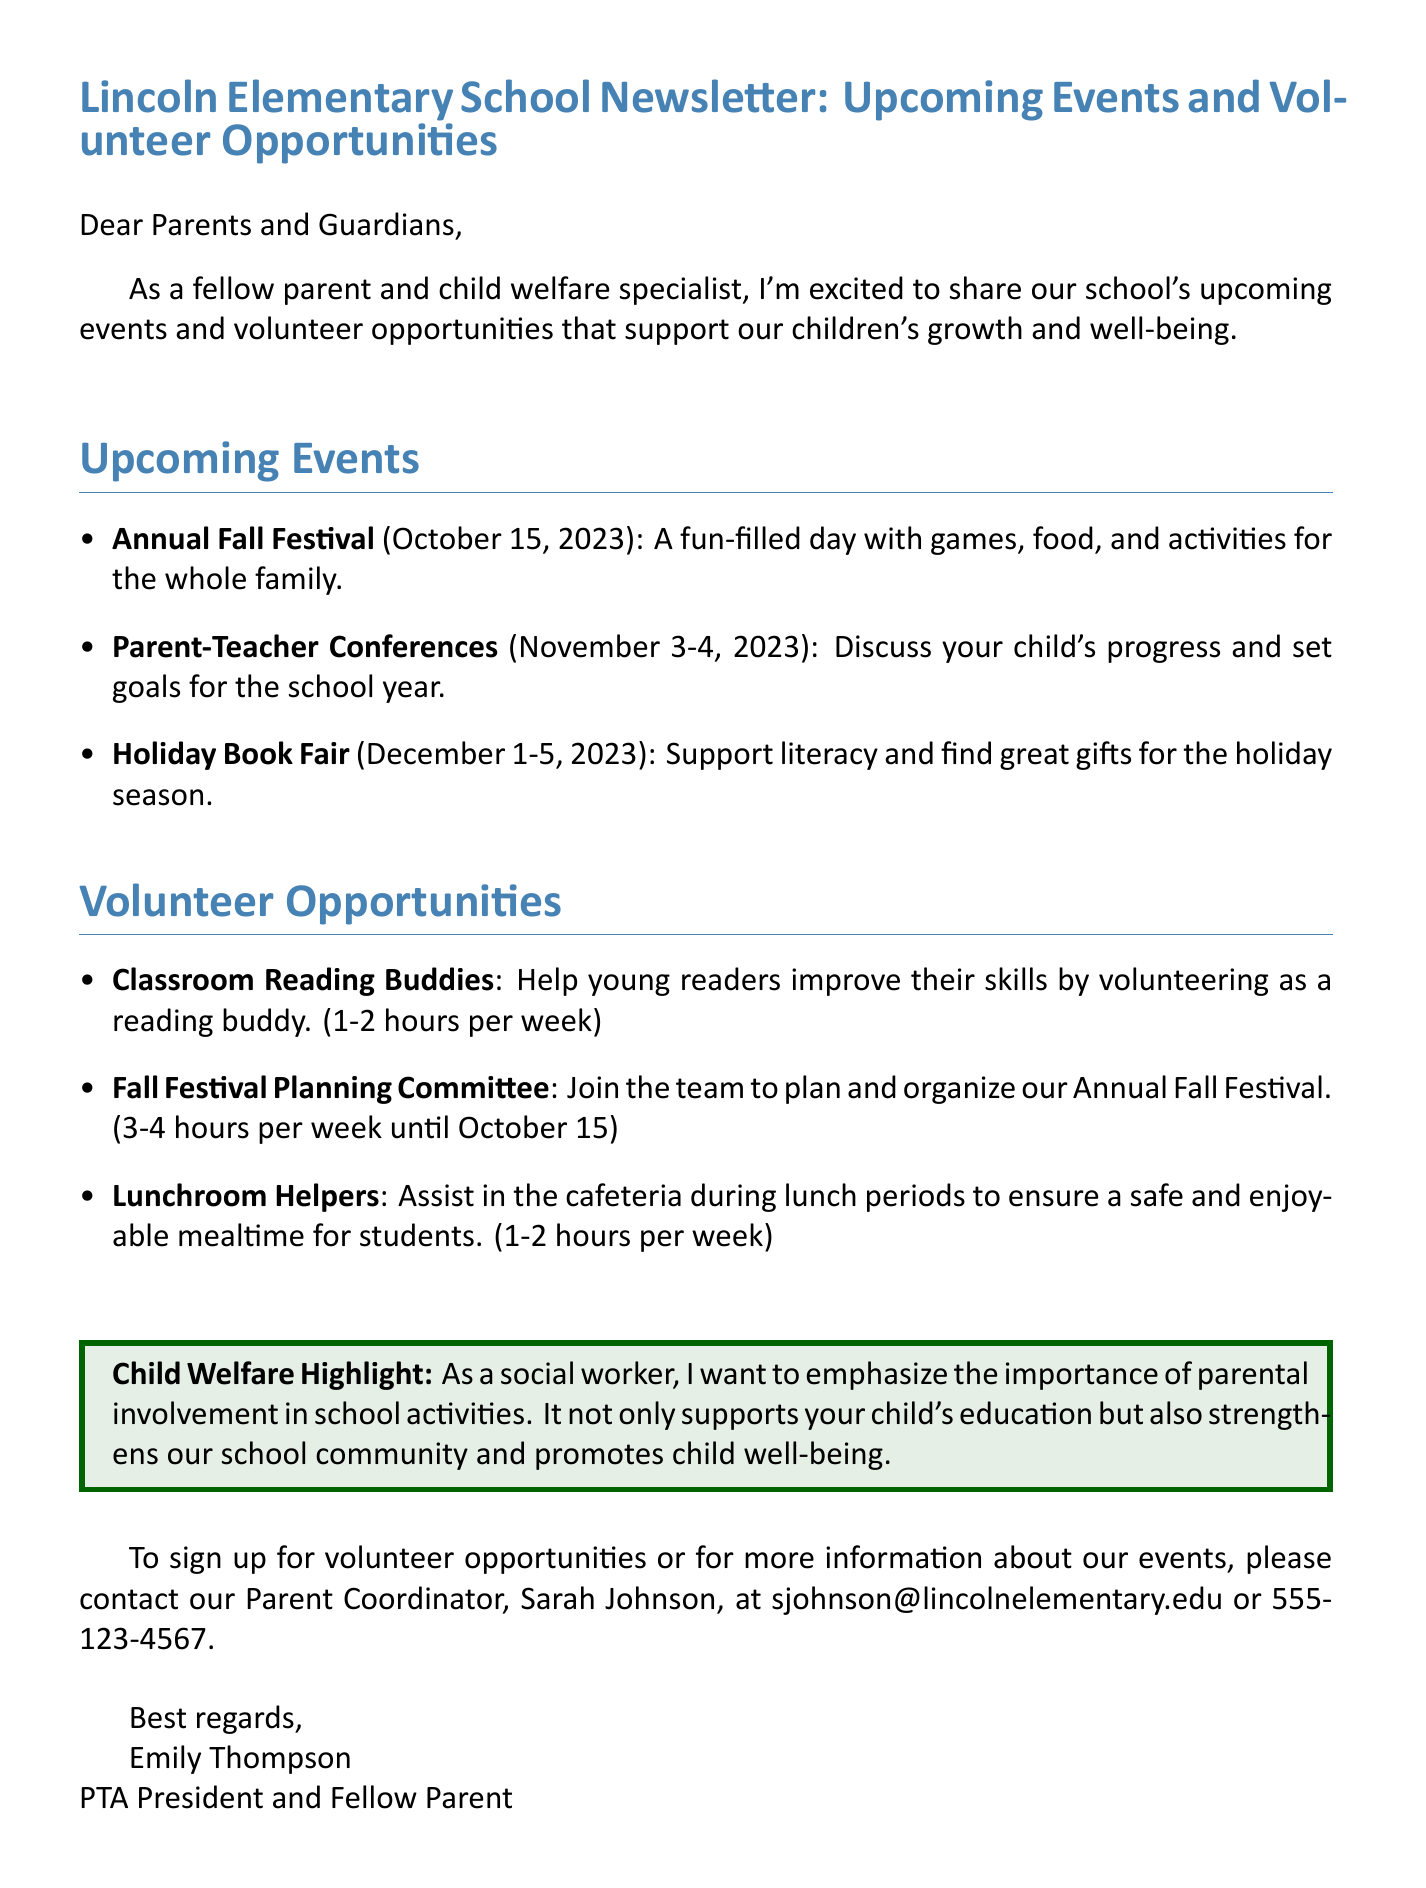what is the subject of the email? The subject indicates the main topic of the email, which is focused on school events and volunteering.
Answer: Lincoln Elementary School Newsletter: Upcoming Events and Volunteer Opportunities when is the Annual Fall Festival? The date specified in the document for the Annual Fall Festival provides exact information about this event.
Answer: October 15, 2023 who is the Parent Coordinator? The document mentions who to contact for signing up for volunteer opportunities and for more information about events.
Answer: Sarah Johnson how many hours are needed for the Fall Festival Planning Committee? The time commitment for this volunteering role is stated in the document as part of the opportunities.
Answer: 3-4 hours per week until October 15 what is the primary highlight related to child welfare mentioned in the document? The highlight emphasizes the importance of a specific action that supports child welfare and community involvement.
Answer: parental involvement in school activities what type of event is scheduled for November 3-4, 2023? The event mentioned during these dates relates to a specific activity between parents and teachers discussed in the document.
Answer: Parent-Teacher Conferences what is the time commitment for Classroom Reading Buddies? The document outlines the time requirement needed for this volunteer position.
Answer: 1-2 hours per week how can parents sign up for volunteer opportunities? The document provides specific instructions on how to engage with volunteer opportunities.
Answer: Contact our Parent Coordinator, Sarah Johnson, at sjohnson@lincolnelementary.edu or 555-123-4567 